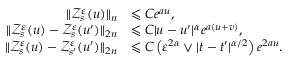<formula> <loc_0><loc_0><loc_500><loc_500>\begin{array} { r l } { \| \ m a t h s c r { Z } _ { s } ^ { \varepsilon } ( u ) \| _ { n } } & { \leqslant C e ^ { a u } , } \\ { \| \ m a t h s c r { Z } _ { s } ^ { \varepsilon } ( u ) - \ m a t h s c r { Z } _ { s } ^ { \varepsilon } ( u ^ { \prime } ) \| _ { 2 n } } & { \leqslant C | u - u ^ { \prime } | ^ { \alpha } e ^ { a ( u + v ) } , } \\ { \| \ m a t h s c r { Z } _ { s } ^ { \varepsilon } ( u ) - \ m a t h s c r { Z } _ { s ^ { \prime } } ^ { \varepsilon } ( u ^ { \prime } ) \| _ { 2 n } } & { \leqslant C \left ( \varepsilon ^ { 2 \alpha } \vee | t - t ^ { \prime } | ^ { \alpha / 2 } \right ) e ^ { 2 a u } . } \end{array}</formula> 